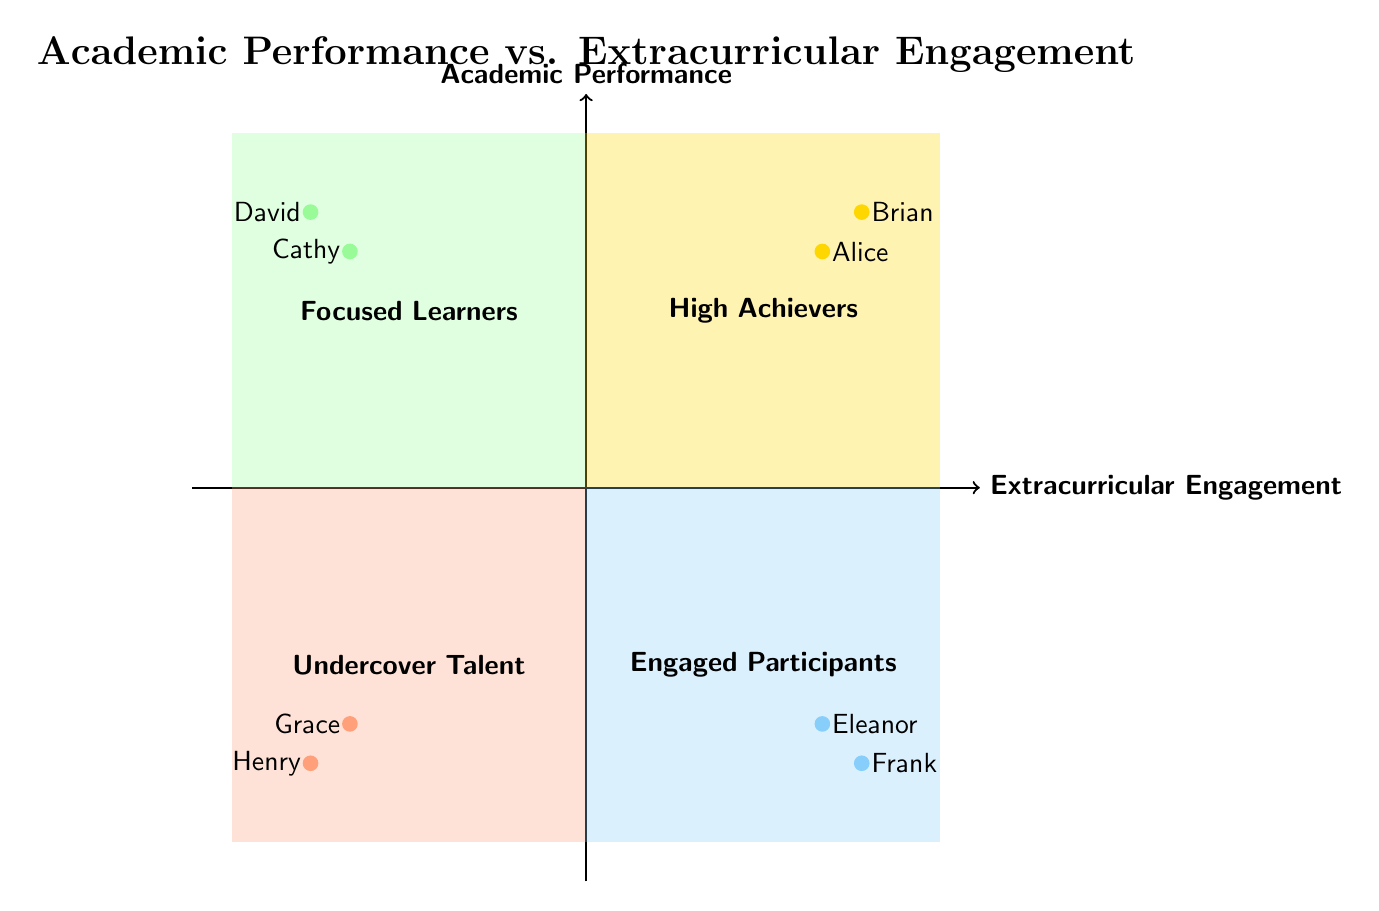What is the title of the diagram? The title can be found at the top of the diagram, which clearly states the focus of the quadrants.
Answer: Academic Performance vs. Extracurricular Engagement What quadrant do Alice and Brian belong to? Alice and Brian are located in the upper right quadrant, signifying high performance and high extracurricular engagement; thus, they belong to the same quadrant.
Answer: High Achievers How many students are categorized as Focused Learners? The Focused Learners quadrant has two example students listed, Cathy and David; counting them gives the total number.
Answer: 2 Which quadrant features students that struggle academically but are involved in many activities? This description aligns with the lower right quadrant, which indicates high engagement but low academic performance, based on the quadrant labeling.
Answer: Engaged Participants What activity does Eleanor participate in? Eleanor's name is listed in the Engaged Participants quadrant along with her activities, which can confirm one of her participations.
Answer: Drama Club Which student represents the Undercover Talent quadrant? The Undercover Talent quadrant indicates students with low performance and low engagement; by reviewing the quadrant, we can identify who fits this category.
Answer: Grace How does the academic performance compare between High Achievers and Engaged Participants? High Achievers is in the upper right quadrant indicating high academic performance while Engaged Participants is in the lower right quadrant indicating lower performance; thus, the comparison shows higher performance in the first.
Answer: Higher Name two activities of David. David is listed in the Focused Learners quadrant, and his specific activities are mentioned, allowing for easy identification.
Answer: Science Club, Math Tutor In which quadrant is Cathy located? The quadrant's labeling allows us to determine Cathy's positioning; particularly, she is in the Focused Learners quadrant as indicated.
Answer: Focused Learners 